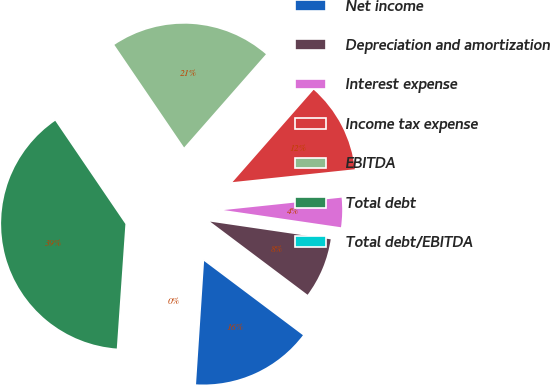Convert chart. <chart><loc_0><loc_0><loc_500><loc_500><pie_chart><fcel>Net income<fcel>Depreciation and amortization<fcel>Interest expense<fcel>Income tax expense<fcel>EBITDA<fcel>Total debt<fcel>Total debt/EBITDA<nl><fcel>15.79%<fcel>7.93%<fcel>3.99%<fcel>11.86%<fcel>20.97%<fcel>39.4%<fcel>0.06%<nl></chart> 